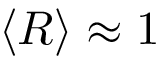Convert formula to latex. <formula><loc_0><loc_0><loc_500><loc_500>\langle R \rangle \approx 1</formula> 